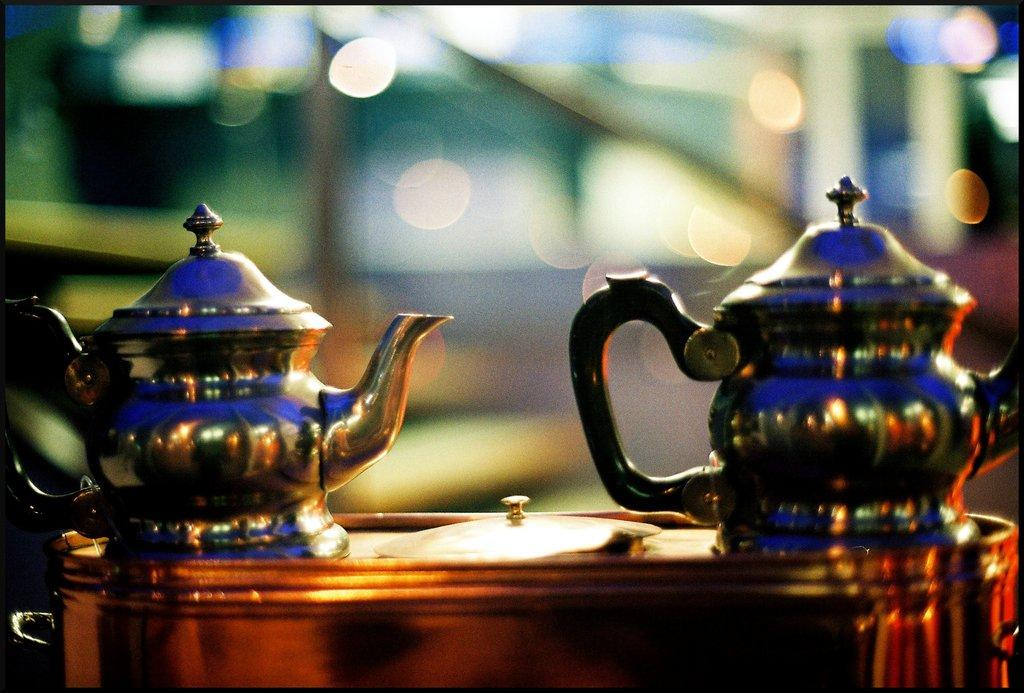What objects are on the table in the image? There are tea jugs on a table in the image. Can you describe the background of the image? The background of the image is blurred. Where is the nest located in the image? There is no nest present in the image. What type of shell can be seen in the image? There is no shell present in the image. 